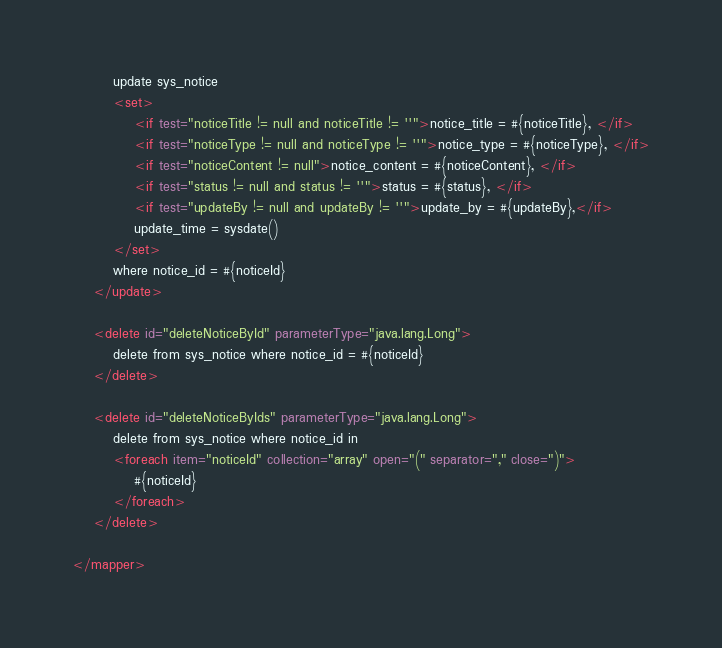<code> <loc_0><loc_0><loc_500><loc_500><_XML_>        update sys_notice 
        <set>
            <if test="noticeTitle != null and noticeTitle != ''">notice_title = #{noticeTitle}, </if>
            <if test="noticeType != null and noticeType != ''">notice_type = #{noticeType}, </if>
            <if test="noticeContent != null">notice_content = #{noticeContent}, </if>
            <if test="status != null and status != ''">status = #{status}, </if>
            <if test="updateBy != null and updateBy != ''">update_by = #{updateBy},</if>
 			update_time = sysdate()
        </set>
        where notice_id = #{noticeId}
    </update>
	
    <delete id="deleteNoticeById" parameterType="java.lang.Long">
        delete from sys_notice where notice_id = #{noticeId}
    </delete>
    
    <delete id="deleteNoticeByIds" parameterType="java.lang.Long">
        delete from sys_notice where notice_id in 
        <foreach item="noticeId" collection="array" open="(" separator="," close=")">
            #{noticeId}
        </foreach>
    </delete>
    
</mapper></code> 